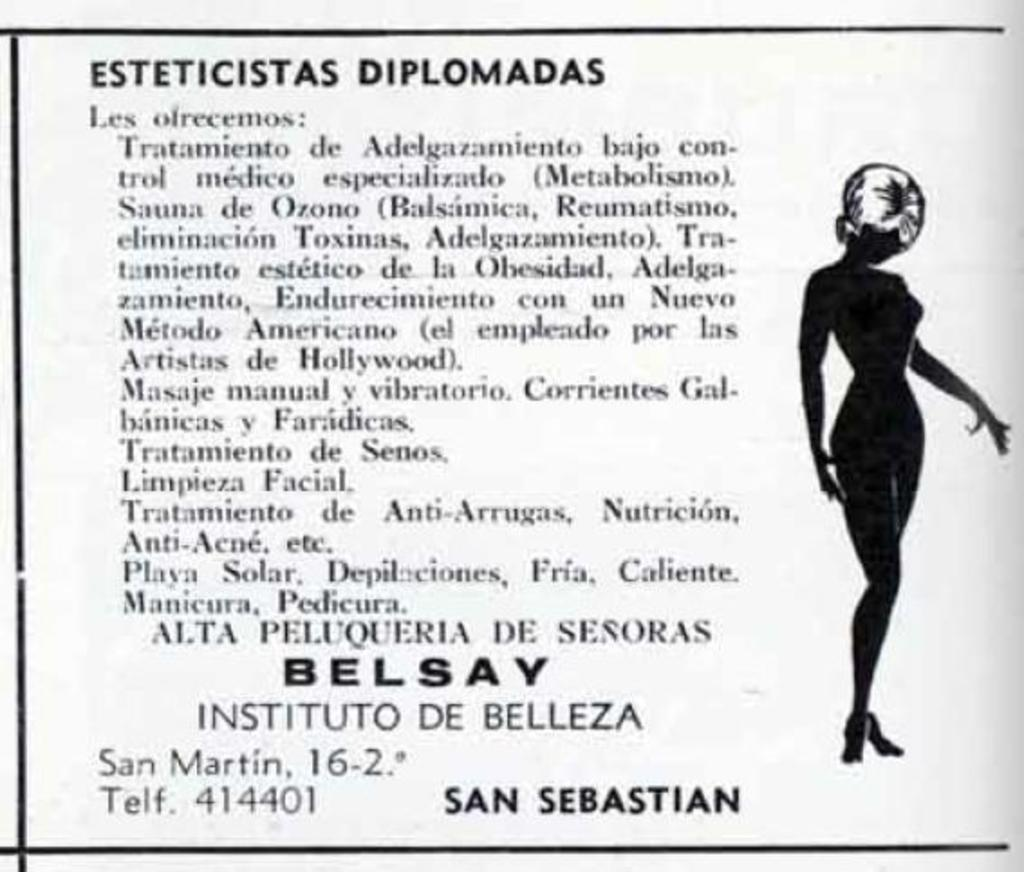What type of image is on the right side of the image? There is a cartoon image of a woman on the right side of the image. What is located on the left side of the image? There is some text on the left side of the image. What type of corn can be seen growing in the image? There is no corn present in the image; it features a cartoon image of a woman and some text. 